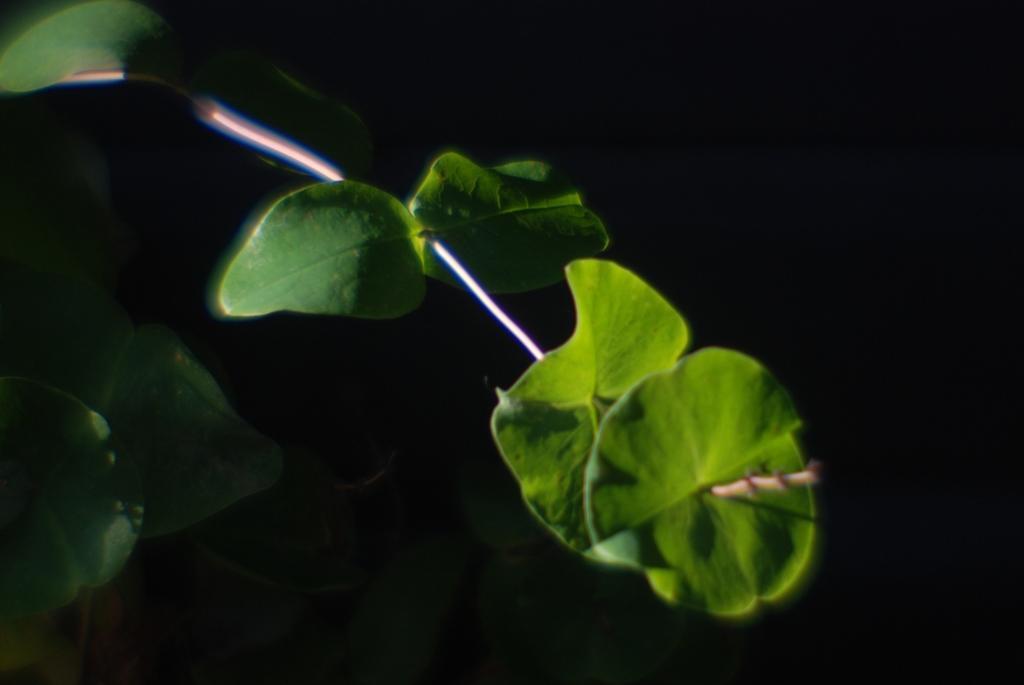Describe this image in one or two sentences. In this image I can see a plant which is green in color and the black background. 